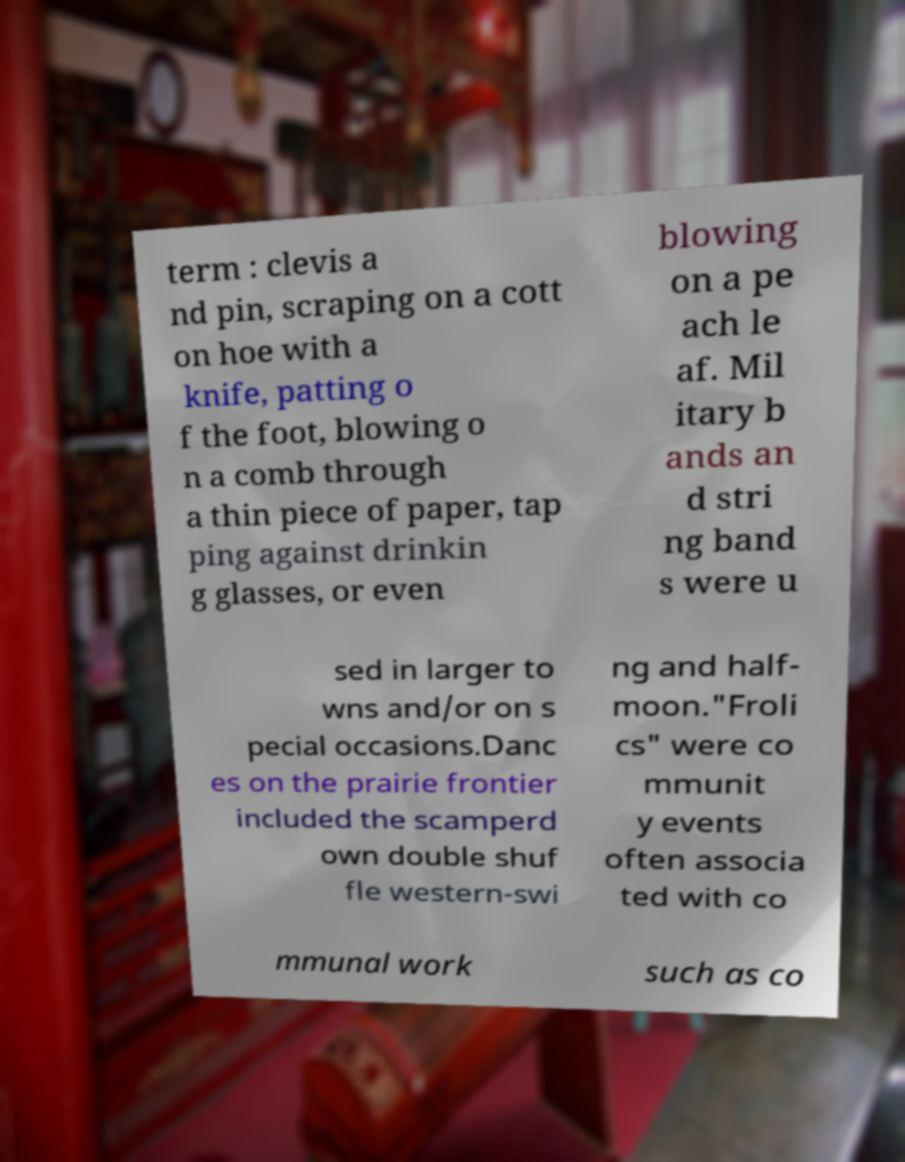Please identify and transcribe the text found in this image. term : clevis a nd pin, scraping on a cott on hoe with a knife, patting o f the foot, blowing o n a comb through a thin piece of paper, tap ping against drinkin g glasses, or even blowing on a pe ach le af. Mil itary b ands an d stri ng band s were u sed in larger to wns and/or on s pecial occasions.Danc es on the prairie frontier included the scamperd own double shuf fle western-swi ng and half- moon."Froli cs" were co mmunit y events often associa ted with co mmunal work such as co 